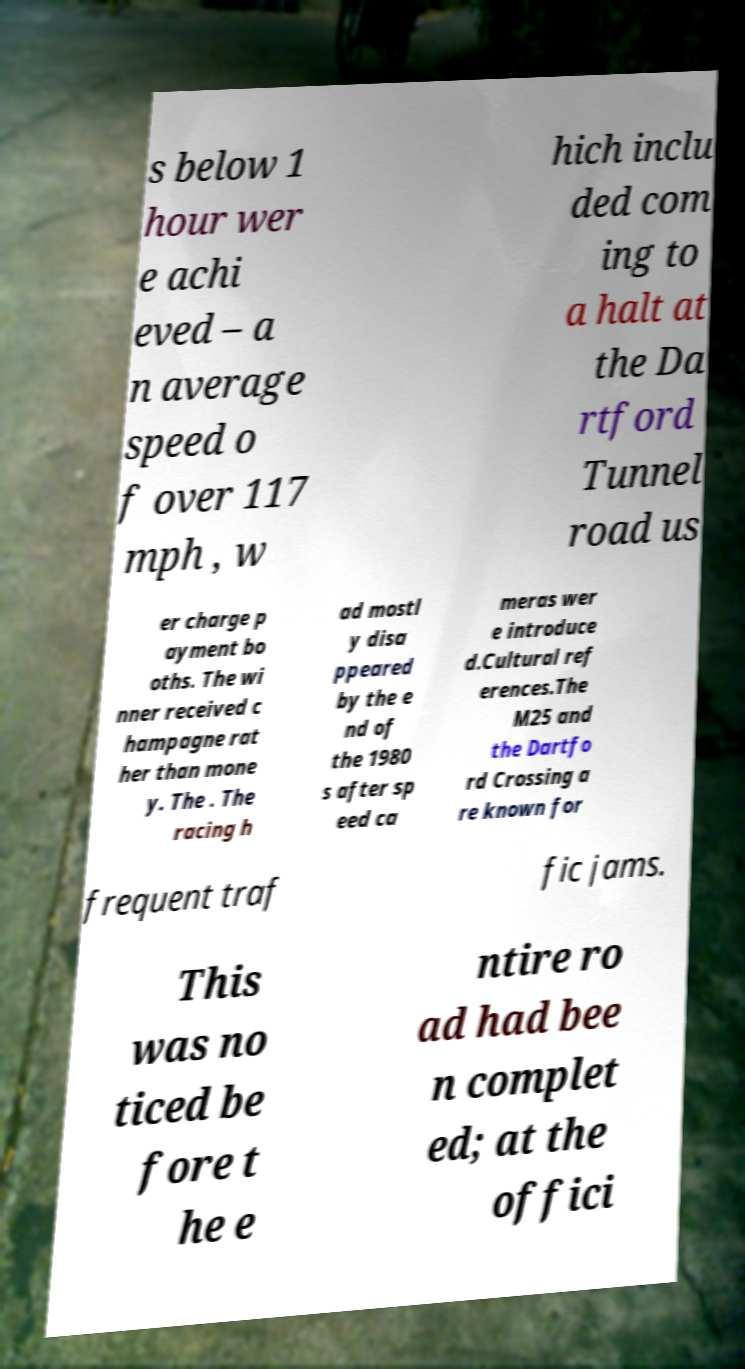Can you read and provide the text displayed in the image?This photo seems to have some interesting text. Can you extract and type it out for me? s below 1 hour wer e achi eved – a n average speed o f over 117 mph , w hich inclu ded com ing to a halt at the Da rtford Tunnel road us er charge p ayment bo oths. The wi nner received c hampagne rat her than mone y. The . The racing h ad mostl y disa ppeared by the e nd of the 1980 s after sp eed ca meras wer e introduce d.Cultural ref erences.The M25 and the Dartfo rd Crossing a re known for frequent traf fic jams. This was no ticed be fore t he e ntire ro ad had bee n complet ed; at the offici 